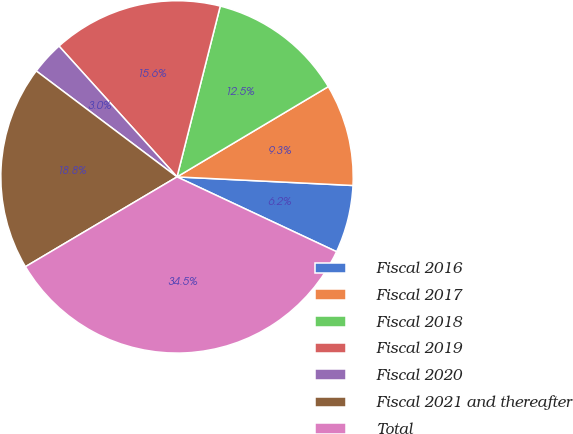Convert chart to OTSL. <chart><loc_0><loc_0><loc_500><loc_500><pie_chart><fcel>Fiscal 2016<fcel>Fiscal 2017<fcel>Fiscal 2018<fcel>Fiscal 2019<fcel>Fiscal 2020<fcel>Fiscal 2021 and thereafter<fcel>Total<nl><fcel>6.2%<fcel>9.34%<fcel>12.49%<fcel>15.63%<fcel>3.05%<fcel>18.78%<fcel>34.51%<nl></chart> 